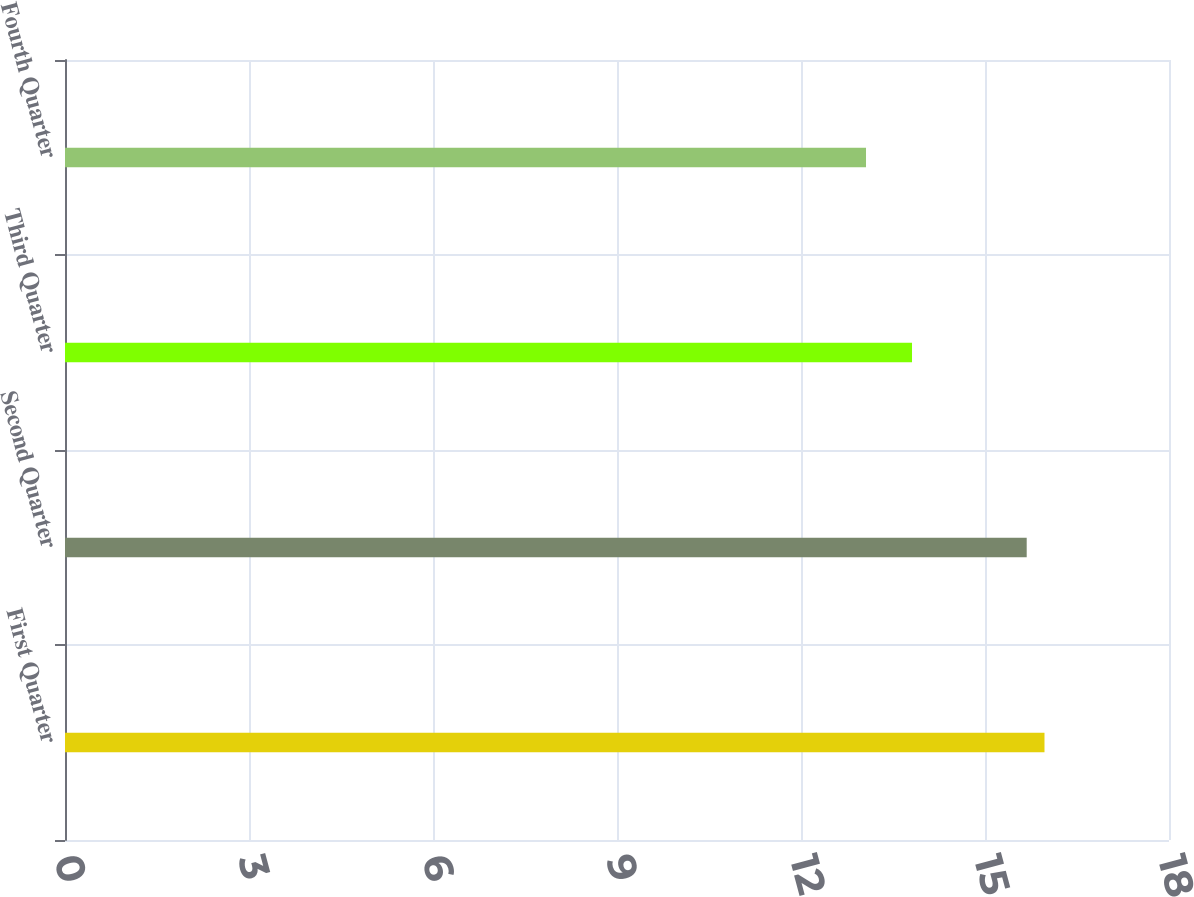<chart> <loc_0><loc_0><loc_500><loc_500><bar_chart><fcel>First Quarter<fcel>Second Quarter<fcel>Third Quarter<fcel>Fourth Quarter<nl><fcel>15.97<fcel>15.68<fcel>13.81<fcel>13.06<nl></chart> 